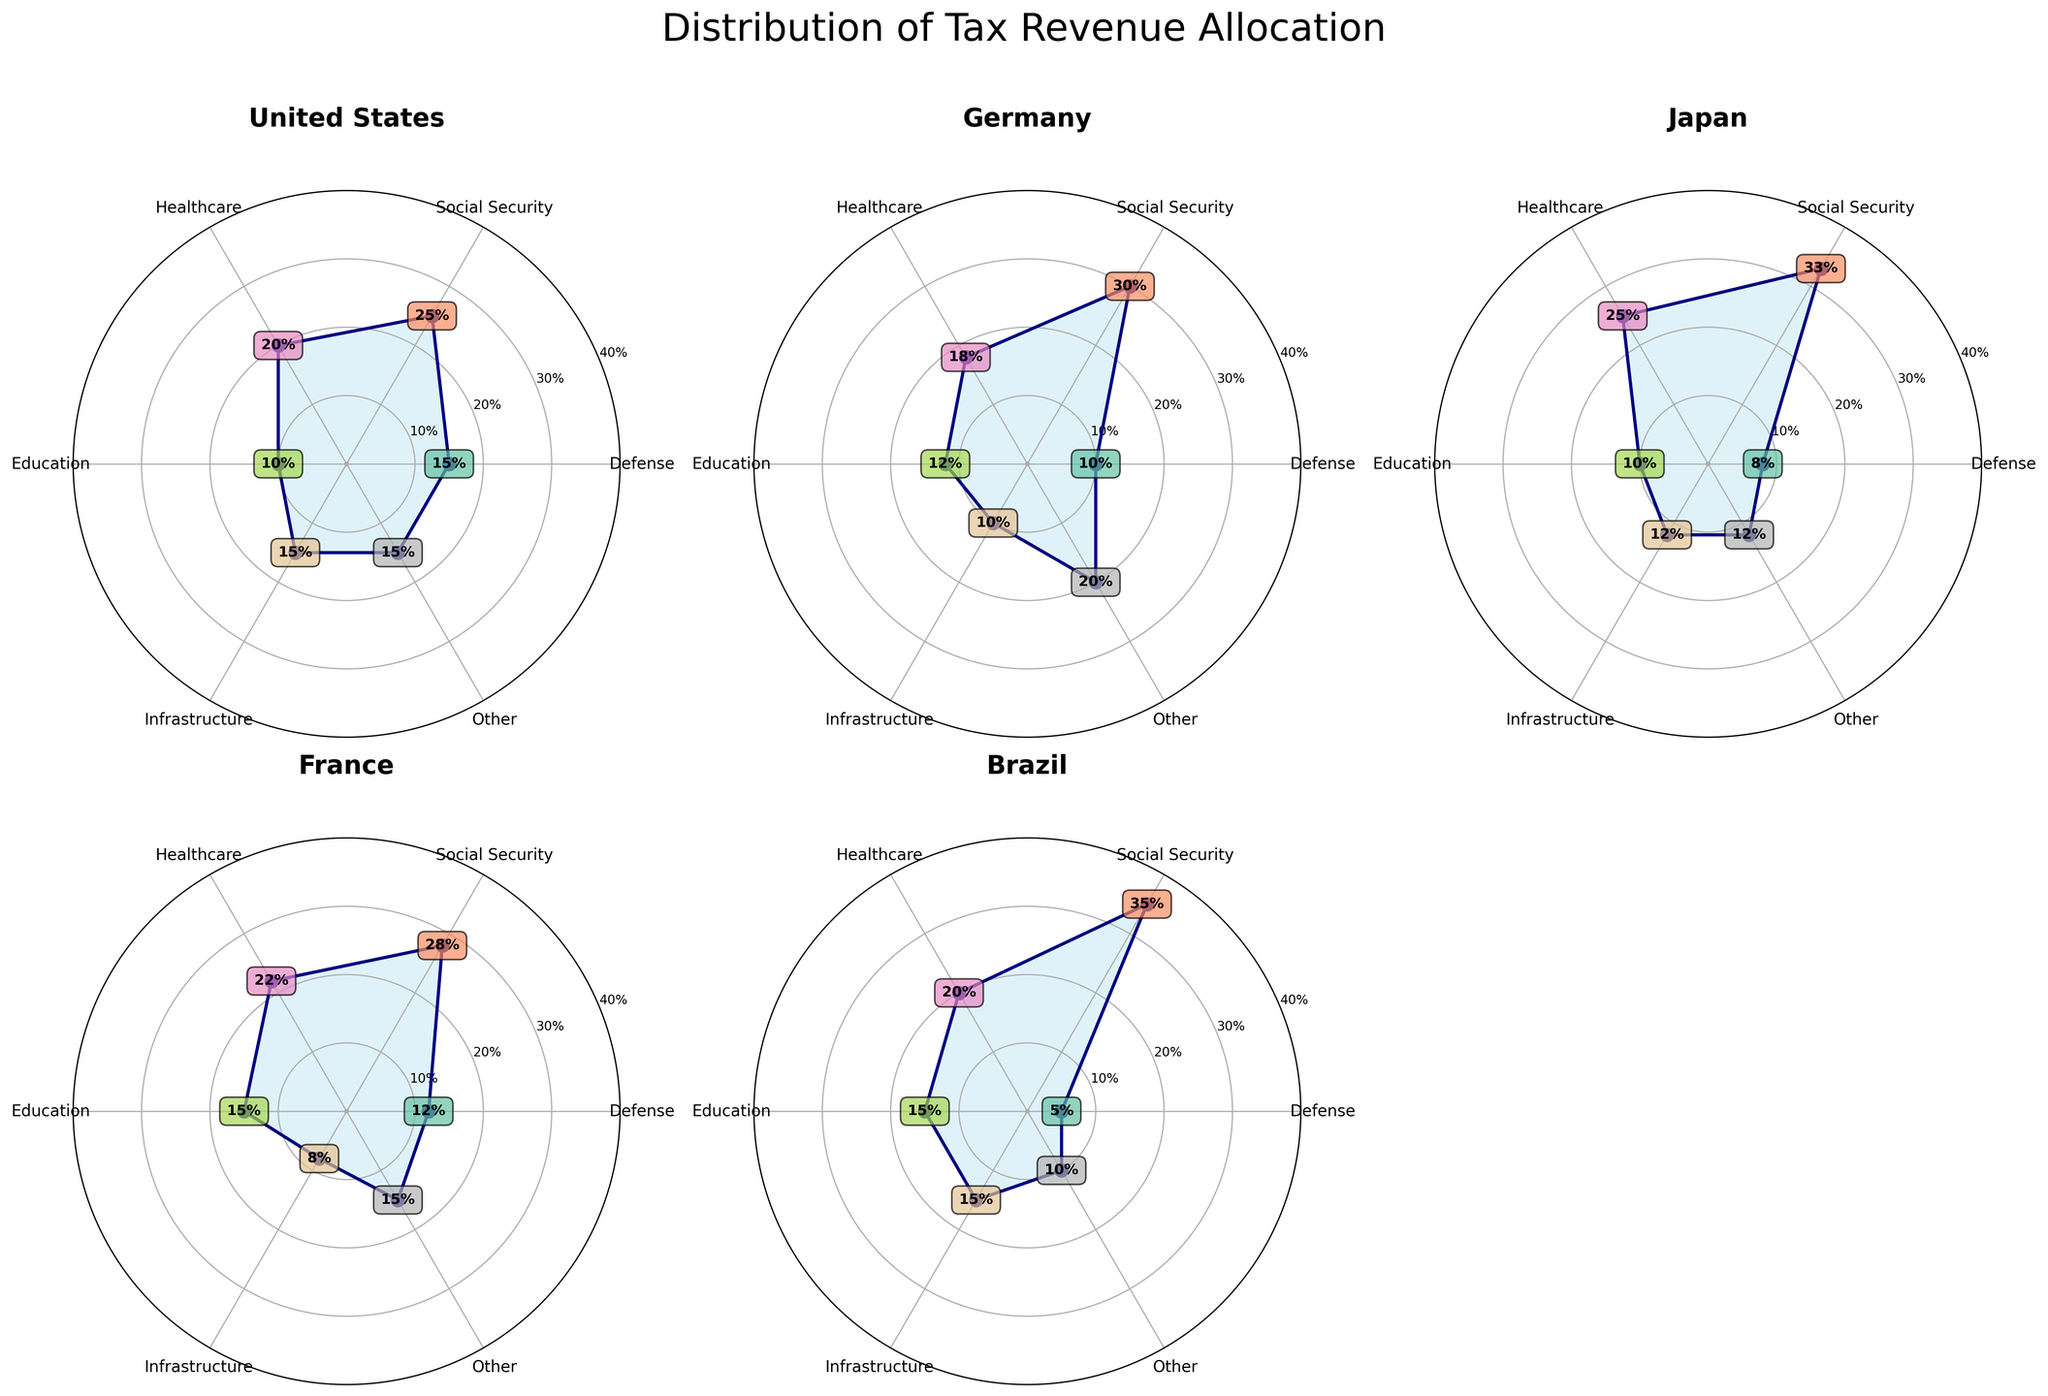How is the tax revenue allocation for healthcare visualized across the countries? Look at the "Healthcare" segments represented by specific percentages in the polar plots for each country.
Answer: Varies from 18% to 25% What is the sum of the percentages of tax revenue allocated to Defense and Education in the United States? Identify the values for Defense (15%) and Education (10%) in the United States' plot, and then add them.
Answer: 25% Which country allocates the highest percentage of its tax revenue to Social Security? Compare the Social Security percentages in the respective polar plots for each country to find the highest value.
Answer: Japan with 33% Is there any country that has an equal percentage allocation for two different categories? If yes, which country and what are the categories? Look for any matching percentage values within a single country's polar plot.
Answer: Brazil; Infrastructure and Education both at 15% How does the percentage allocation for Defense in Brazil compare to that in France? Locate the Defense percentages in the polar plots for Brazil (5%) and France (12%) and compare them.
Answer: Brazil spends less than France Which category has the smallest variance in percentage allocation across all countries? Inspect all categories and evaluate which one has the least variability in percentages.
Answer: Education (ranging from 10% to 15%) List all countries' tax revenue allocation for the "Other" category. Look at the "Other" category percentages in each country's polar plot: United States (15%), Germany (20%), Japan (12%), France (15%), Brazil (10%).
Answer: United States, 15%; Germany, 20%; Japan, 12%; France, 15%; Brazil, 10% What is the average percentage of tax revenue allocated to Infrastructure across all countries? Add up all the percentages for Infrastructure and divide by the number of countries (5).
Answer: (15% + 10% + 12% + 8% + 15%) / 5 = 12% Between Germany and Japan, which one has a greater focus on Healthcare in terms of tax revenue allocation? Compare the Healthcare percentages for Germany (18%) and Japan (25%) in their respective polar plots.
Answer: Japan If you exclude the "Other" category, what is the new total sum of percentages for the United States, and does it still sum up to 100%? Subtract the "Other" percentage (15%) from the total (100%) and check the sum of remaining categories (85%).
Answer: 100% (Yes) 